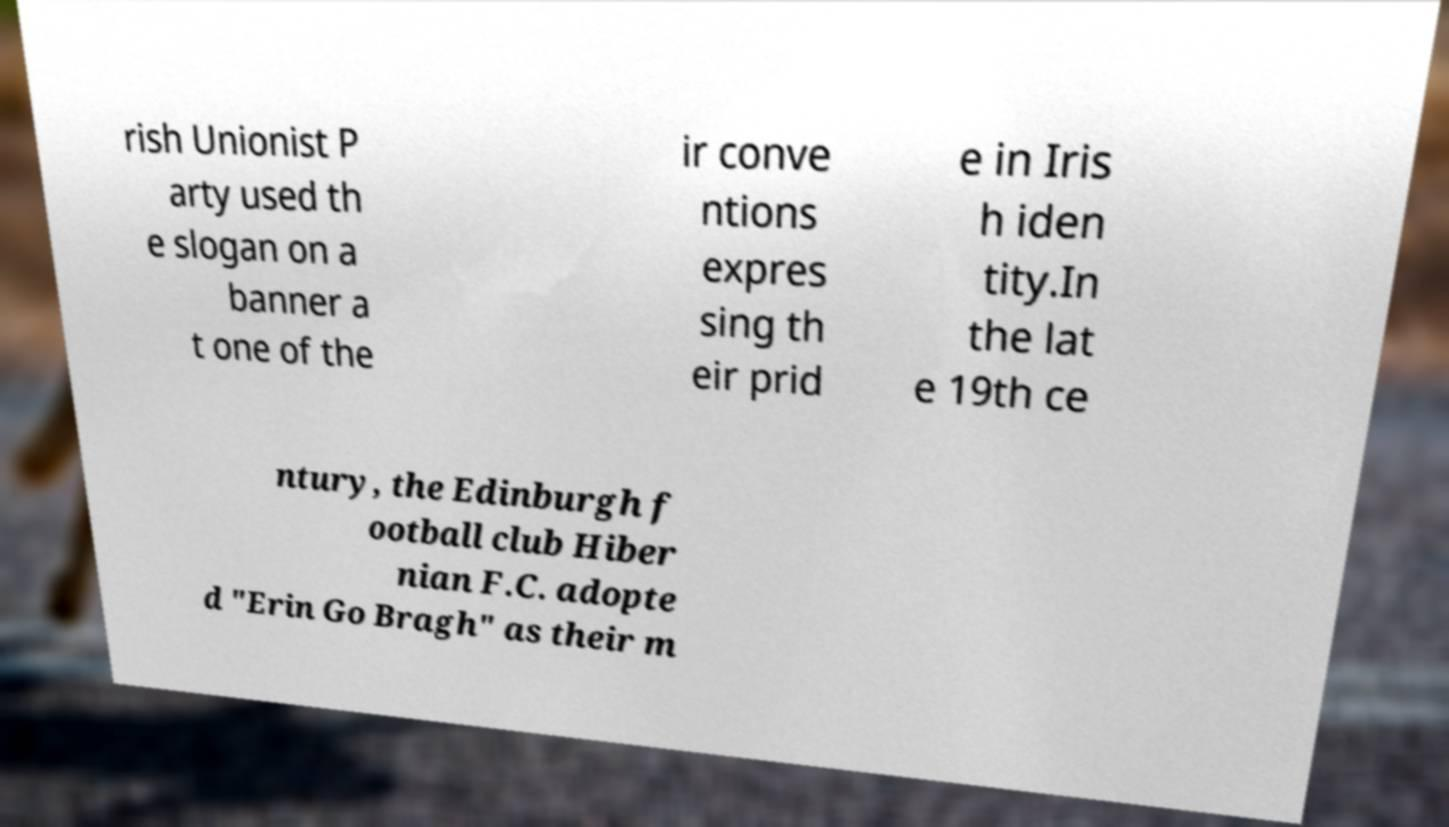Please identify and transcribe the text found in this image. rish Unionist P arty used th e slogan on a banner a t one of the ir conve ntions expres sing th eir prid e in Iris h iden tity.In the lat e 19th ce ntury, the Edinburgh f ootball club Hiber nian F.C. adopte d "Erin Go Bragh" as their m 